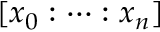Convert formula to latex. <formula><loc_0><loc_0><loc_500><loc_500>[ x _ { 0 } \colon \cdots \colon x _ { n } ]</formula> 